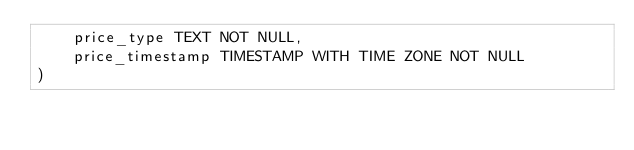Convert code to text. <code><loc_0><loc_0><loc_500><loc_500><_SQL_>    price_type TEXT NOT NULL,
    price_timestamp TIMESTAMP WITH TIME ZONE NOT NULL
)
</code> 